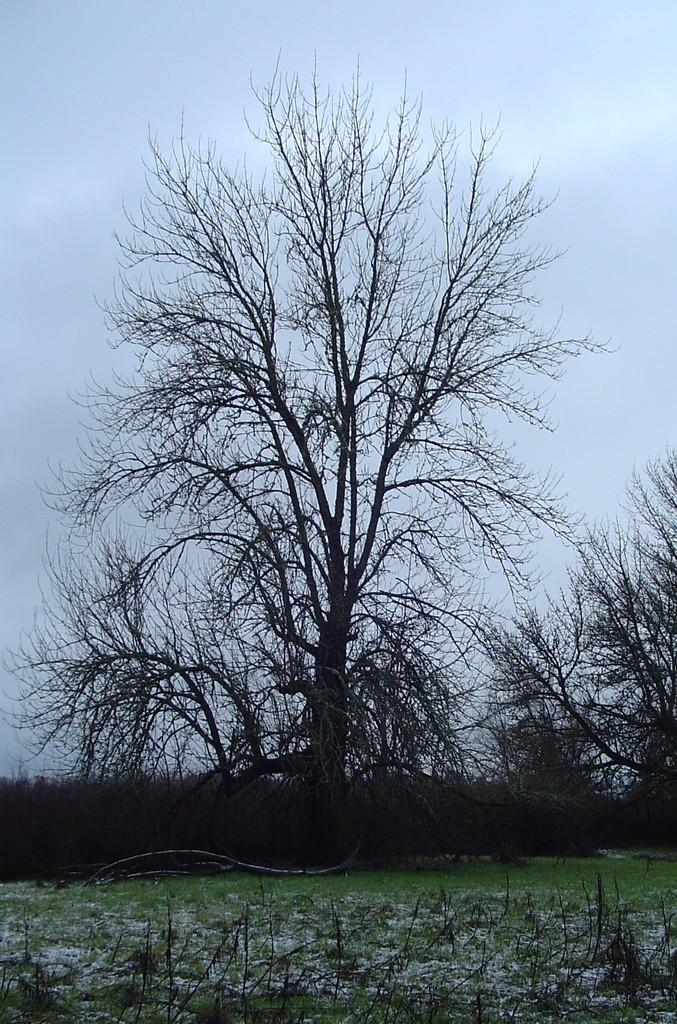What type of vegetation can be seen in the image? There are trees and plants in the image. What is visible at the top of the image? The sky is visible at the top of the image. What is present at the bottom of the image? There is grass at the bottom of the image. Can you describe a specific part of a tree in the image? There is a tree branch in the image. How many frogs are sitting on the tree branch in the image? There are no frogs present in the image; it only features trees, plants, grass, and a tree branch. What type of disease can be seen affecting the plants in the image? There is no indication of any disease affecting the plants in the image. 